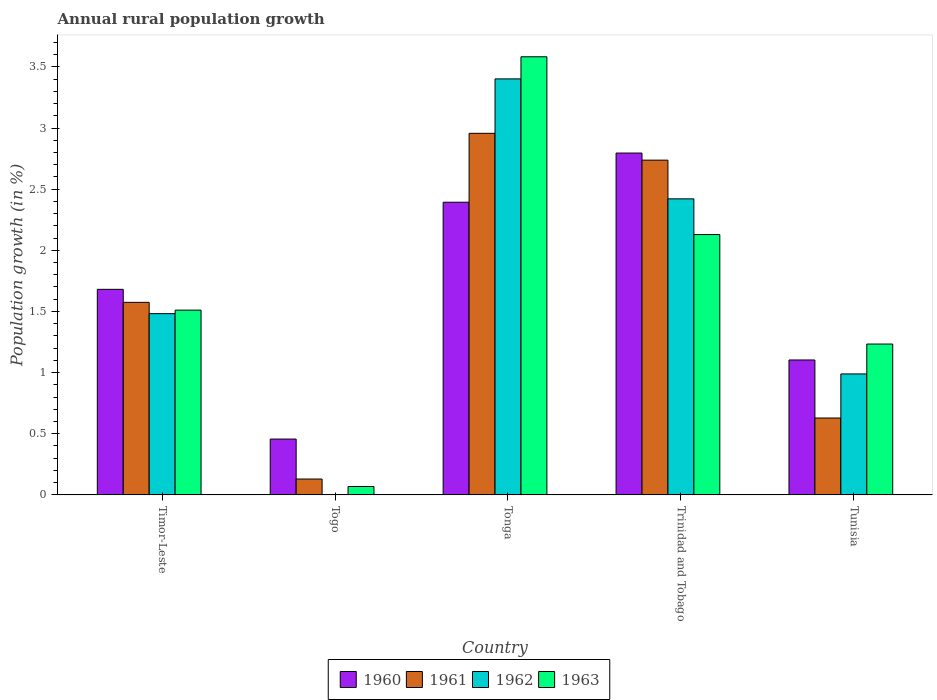How many different coloured bars are there?
Your response must be concise. 4. How many bars are there on the 2nd tick from the left?
Offer a terse response. 3. What is the label of the 1st group of bars from the left?
Make the answer very short. Timor-Leste. What is the percentage of rural population growth in 1960 in Timor-Leste?
Offer a terse response. 1.68. Across all countries, what is the maximum percentage of rural population growth in 1961?
Provide a short and direct response. 2.96. Across all countries, what is the minimum percentage of rural population growth in 1960?
Give a very brief answer. 0.46. In which country was the percentage of rural population growth in 1963 maximum?
Your answer should be very brief. Tonga. What is the total percentage of rural population growth in 1961 in the graph?
Provide a short and direct response. 8.03. What is the difference between the percentage of rural population growth in 1961 in Tonga and that in Tunisia?
Offer a very short reply. 2.33. What is the difference between the percentage of rural population growth in 1961 in Togo and the percentage of rural population growth in 1960 in Trinidad and Tobago?
Provide a short and direct response. -2.67. What is the average percentage of rural population growth in 1963 per country?
Provide a short and direct response. 1.7. What is the difference between the percentage of rural population growth of/in 1963 and percentage of rural population growth of/in 1960 in Trinidad and Tobago?
Offer a terse response. -0.67. In how many countries, is the percentage of rural population growth in 1963 greater than 3.1 %?
Make the answer very short. 1. What is the ratio of the percentage of rural population growth in 1960 in Togo to that in Tonga?
Give a very brief answer. 0.19. Is the difference between the percentage of rural population growth in 1963 in Trinidad and Tobago and Tunisia greater than the difference between the percentage of rural population growth in 1960 in Trinidad and Tobago and Tunisia?
Offer a very short reply. No. What is the difference between the highest and the second highest percentage of rural population growth in 1963?
Provide a short and direct response. -0.62. What is the difference between the highest and the lowest percentage of rural population growth in 1960?
Make the answer very short. 2.34. In how many countries, is the percentage of rural population growth in 1960 greater than the average percentage of rural population growth in 1960 taken over all countries?
Your response must be concise. 2. Is the sum of the percentage of rural population growth in 1963 in Togo and Tunisia greater than the maximum percentage of rural population growth in 1960 across all countries?
Offer a very short reply. No. Is it the case that in every country, the sum of the percentage of rural population growth in 1962 and percentage of rural population growth in 1961 is greater than the percentage of rural population growth in 1963?
Give a very brief answer. Yes. How many countries are there in the graph?
Make the answer very short. 5. What is the difference between two consecutive major ticks on the Y-axis?
Keep it short and to the point. 0.5. Where does the legend appear in the graph?
Keep it short and to the point. Bottom center. How many legend labels are there?
Provide a succinct answer. 4. What is the title of the graph?
Provide a succinct answer. Annual rural population growth. Does "1981" appear as one of the legend labels in the graph?
Make the answer very short. No. What is the label or title of the Y-axis?
Offer a terse response. Population growth (in %). What is the Population growth (in %) in 1960 in Timor-Leste?
Offer a terse response. 1.68. What is the Population growth (in %) in 1961 in Timor-Leste?
Provide a succinct answer. 1.57. What is the Population growth (in %) in 1962 in Timor-Leste?
Offer a terse response. 1.48. What is the Population growth (in %) of 1963 in Timor-Leste?
Give a very brief answer. 1.51. What is the Population growth (in %) of 1960 in Togo?
Your answer should be very brief. 0.46. What is the Population growth (in %) in 1961 in Togo?
Make the answer very short. 0.13. What is the Population growth (in %) of 1962 in Togo?
Provide a short and direct response. 0. What is the Population growth (in %) of 1963 in Togo?
Ensure brevity in your answer.  0.07. What is the Population growth (in %) of 1960 in Tonga?
Your response must be concise. 2.39. What is the Population growth (in %) of 1961 in Tonga?
Keep it short and to the point. 2.96. What is the Population growth (in %) of 1962 in Tonga?
Your answer should be compact. 3.4. What is the Population growth (in %) in 1963 in Tonga?
Your response must be concise. 3.58. What is the Population growth (in %) in 1960 in Trinidad and Tobago?
Give a very brief answer. 2.8. What is the Population growth (in %) in 1961 in Trinidad and Tobago?
Your answer should be compact. 2.74. What is the Population growth (in %) in 1962 in Trinidad and Tobago?
Provide a succinct answer. 2.42. What is the Population growth (in %) in 1963 in Trinidad and Tobago?
Ensure brevity in your answer.  2.13. What is the Population growth (in %) in 1960 in Tunisia?
Offer a very short reply. 1.1. What is the Population growth (in %) in 1961 in Tunisia?
Give a very brief answer. 0.63. What is the Population growth (in %) in 1962 in Tunisia?
Provide a succinct answer. 0.99. What is the Population growth (in %) in 1963 in Tunisia?
Provide a short and direct response. 1.23. Across all countries, what is the maximum Population growth (in %) in 1960?
Your answer should be compact. 2.8. Across all countries, what is the maximum Population growth (in %) of 1961?
Offer a terse response. 2.96. Across all countries, what is the maximum Population growth (in %) in 1962?
Your answer should be very brief. 3.4. Across all countries, what is the maximum Population growth (in %) of 1963?
Give a very brief answer. 3.58. Across all countries, what is the minimum Population growth (in %) in 1960?
Your response must be concise. 0.46. Across all countries, what is the minimum Population growth (in %) in 1961?
Give a very brief answer. 0.13. Across all countries, what is the minimum Population growth (in %) in 1963?
Give a very brief answer. 0.07. What is the total Population growth (in %) in 1960 in the graph?
Offer a terse response. 8.43. What is the total Population growth (in %) of 1961 in the graph?
Provide a succinct answer. 8.03. What is the total Population growth (in %) of 1962 in the graph?
Make the answer very short. 8.29. What is the total Population growth (in %) in 1963 in the graph?
Give a very brief answer. 8.52. What is the difference between the Population growth (in %) of 1960 in Timor-Leste and that in Togo?
Ensure brevity in your answer.  1.22. What is the difference between the Population growth (in %) of 1961 in Timor-Leste and that in Togo?
Ensure brevity in your answer.  1.44. What is the difference between the Population growth (in %) in 1963 in Timor-Leste and that in Togo?
Offer a terse response. 1.44. What is the difference between the Population growth (in %) in 1960 in Timor-Leste and that in Tonga?
Your answer should be compact. -0.71. What is the difference between the Population growth (in %) in 1961 in Timor-Leste and that in Tonga?
Offer a terse response. -1.38. What is the difference between the Population growth (in %) in 1962 in Timor-Leste and that in Tonga?
Your answer should be very brief. -1.92. What is the difference between the Population growth (in %) in 1963 in Timor-Leste and that in Tonga?
Offer a very short reply. -2.07. What is the difference between the Population growth (in %) in 1960 in Timor-Leste and that in Trinidad and Tobago?
Your response must be concise. -1.11. What is the difference between the Population growth (in %) in 1961 in Timor-Leste and that in Trinidad and Tobago?
Give a very brief answer. -1.16. What is the difference between the Population growth (in %) of 1962 in Timor-Leste and that in Trinidad and Tobago?
Make the answer very short. -0.94. What is the difference between the Population growth (in %) of 1963 in Timor-Leste and that in Trinidad and Tobago?
Give a very brief answer. -0.62. What is the difference between the Population growth (in %) of 1960 in Timor-Leste and that in Tunisia?
Give a very brief answer. 0.58. What is the difference between the Population growth (in %) of 1961 in Timor-Leste and that in Tunisia?
Offer a terse response. 0.95. What is the difference between the Population growth (in %) of 1962 in Timor-Leste and that in Tunisia?
Give a very brief answer. 0.49. What is the difference between the Population growth (in %) in 1963 in Timor-Leste and that in Tunisia?
Give a very brief answer. 0.28. What is the difference between the Population growth (in %) of 1960 in Togo and that in Tonga?
Provide a short and direct response. -1.94. What is the difference between the Population growth (in %) in 1961 in Togo and that in Tonga?
Your answer should be very brief. -2.83. What is the difference between the Population growth (in %) of 1963 in Togo and that in Tonga?
Your answer should be compact. -3.51. What is the difference between the Population growth (in %) of 1960 in Togo and that in Trinidad and Tobago?
Provide a short and direct response. -2.34. What is the difference between the Population growth (in %) in 1961 in Togo and that in Trinidad and Tobago?
Your answer should be compact. -2.61. What is the difference between the Population growth (in %) in 1963 in Togo and that in Trinidad and Tobago?
Make the answer very short. -2.06. What is the difference between the Population growth (in %) of 1960 in Togo and that in Tunisia?
Provide a succinct answer. -0.65. What is the difference between the Population growth (in %) of 1961 in Togo and that in Tunisia?
Offer a terse response. -0.5. What is the difference between the Population growth (in %) in 1963 in Togo and that in Tunisia?
Make the answer very short. -1.17. What is the difference between the Population growth (in %) of 1960 in Tonga and that in Trinidad and Tobago?
Your response must be concise. -0.4. What is the difference between the Population growth (in %) in 1961 in Tonga and that in Trinidad and Tobago?
Ensure brevity in your answer.  0.22. What is the difference between the Population growth (in %) of 1962 in Tonga and that in Trinidad and Tobago?
Your answer should be very brief. 0.98. What is the difference between the Population growth (in %) of 1963 in Tonga and that in Trinidad and Tobago?
Ensure brevity in your answer.  1.45. What is the difference between the Population growth (in %) of 1960 in Tonga and that in Tunisia?
Offer a terse response. 1.29. What is the difference between the Population growth (in %) of 1961 in Tonga and that in Tunisia?
Your answer should be compact. 2.33. What is the difference between the Population growth (in %) of 1962 in Tonga and that in Tunisia?
Your response must be concise. 2.41. What is the difference between the Population growth (in %) of 1963 in Tonga and that in Tunisia?
Your answer should be very brief. 2.35. What is the difference between the Population growth (in %) in 1960 in Trinidad and Tobago and that in Tunisia?
Make the answer very short. 1.69. What is the difference between the Population growth (in %) in 1961 in Trinidad and Tobago and that in Tunisia?
Make the answer very short. 2.11. What is the difference between the Population growth (in %) in 1962 in Trinidad and Tobago and that in Tunisia?
Give a very brief answer. 1.43. What is the difference between the Population growth (in %) in 1963 in Trinidad and Tobago and that in Tunisia?
Ensure brevity in your answer.  0.9. What is the difference between the Population growth (in %) of 1960 in Timor-Leste and the Population growth (in %) of 1961 in Togo?
Give a very brief answer. 1.55. What is the difference between the Population growth (in %) of 1960 in Timor-Leste and the Population growth (in %) of 1963 in Togo?
Offer a terse response. 1.61. What is the difference between the Population growth (in %) of 1961 in Timor-Leste and the Population growth (in %) of 1963 in Togo?
Offer a terse response. 1.51. What is the difference between the Population growth (in %) of 1962 in Timor-Leste and the Population growth (in %) of 1963 in Togo?
Provide a succinct answer. 1.41. What is the difference between the Population growth (in %) in 1960 in Timor-Leste and the Population growth (in %) in 1961 in Tonga?
Offer a very short reply. -1.28. What is the difference between the Population growth (in %) of 1960 in Timor-Leste and the Population growth (in %) of 1962 in Tonga?
Provide a succinct answer. -1.72. What is the difference between the Population growth (in %) of 1960 in Timor-Leste and the Population growth (in %) of 1963 in Tonga?
Provide a short and direct response. -1.9. What is the difference between the Population growth (in %) in 1961 in Timor-Leste and the Population growth (in %) in 1962 in Tonga?
Offer a very short reply. -1.83. What is the difference between the Population growth (in %) in 1961 in Timor-Leste and the Population growth (in %) in 1963 in Tonga?
Offer a very short reply. -2.01. What is the difference between the Population growth (in %) of 1962 in Timor-Leste and the Population growth (in %) of 1963 in Tonga?
Your answer should be compact. -2.1. What is the difference between the Population growth (in %) in 1960 in Timor-Leste and the Population growth (in %) in 1961 in Trinidad and Tobago?
Give a very brief answer. -1.06. What is the difference between the Population growth (in %) in 1960 in Timor-Leste and the Population growth (in %) in 1962 in Trinidad and Tobago?
Give a very brief answer. -0.74. What is the difference between the Population growth (in %) of 1960 in Timor-Leste and the Population growth (in %) of 1963 in Trinidad and Tobago?
Keep it short and to the point. -0.45. What is the difference between the Population growth (in %) of 1961 in Timor-Leste and the Population growth (in %) of 1962 in Trinidad and Tobago?
Your answer should be compact. -0.85. What is the difference between the Population growth (in %) in 1961 in Timor-Leste and the Population growth (in %) in 1963 in Trinidad and Tobago?
Give a very brief answer. -0.55. What is the difference between the Population growth (in %) of 1962 in Timor-Leste and the Population growth (in %) of 1963 in Trinidad and Tobago?
Ensure brevity in your answer.  -0.65. What is the difference between the Population growth (in %) of 1960 in Timor-Leste and the Population growth (in %) of 1961 in Tunisia?
Your answer should be very brief. 1.05. What is the difference between the Population growth (in %) in 1960 in Timor-Leste and the Population growth (in %) in 1962 in Tunisia?
Provide a succinct answer. 0.69. What is the difference between the Population growth (in %) of 1960 in Timor-Leste and the Population growth (in %) of 1963 in Tunisia?
Offer a terse response. 0.45. What is the difference between the Population growth (in %) in 1961 in Timor-Leste and the Population growth (in %) in 1962 in Tunisia?
Give a very brief answer. 0.59. What is the difference between the Population growth (in %) of 1961 in Timor-Leste and the Population growth (in %) of 1963 in Tunisia?
Your answer should be very brief. 0.34. What is the difference between the Population growth (in %) of 1962 in Timor-Leste and the Population growth (in %) of 1963 in Tunisia?
Keep it short and to the point. 0.25. What is the difference between the Population growth (in %) in 1960 in Togo and the Population growth (in %) in 1961 in Tonga?
Keep it short and to the point. -2.5. What is the difference between the Population growth (in %) in 1960 in Togo and the Population growth (in %) in 1962 in Tonga?
Give a very brief answer. -2.94. What is the difference between the Population growth (in %) in 1960 in Togo and the Population growth (in %) in 1963 in Tonga?
Provide a short and direct response. -3.13. What is the difference between the Population growth (in %) of 1961 in Togo and the Population growth (in %) of 1962 in Tonga?
Your answer should be very brief. -3.27. What is the difference between the Population growth (in %) in 1961 in Togo and the Population growth (in %) in 1963 in Tonga?
Your answer should be very brief. -3.45. What is the difference between the Population growth (in %) in 1960 in Togo and the Population growth (in %) in 1961 in Trinidad and Tobago?
Make the answer very short. -2.28. What is the difference between the Population growth (in %) in 1960 in Togo and the Population growth (in %) in 1962 in Trinidad and Tobago?
Give a very brief answer. -1.96. What is the difference between the Population growth (in %) in 1960 in Togo and the Population growth (in %) in 1963 in Trinidad and Tobago?
Provide a succinct answer. -1.67. What is the difference between the Population growth (in %) of 1961 in Togo and the Population growth (in %) of 1962 in Trinidad and Tobago?
Provide a short and direct response. -2.29. What is the difference between the Population growth (in %) in 1961 in Togo and the Population growth (in %) in 1963 in Trinidad and Tobago?
Provide a short and direct response. -2. What is the difference between the Population growth (in %) in 1960 in Togo and the Population growth (in %) in 1961 in Tunisia?
Provide a succinct answer. -0.17. What is the difference between the Population growth (in %) in 1960 in Togo and the Population growth (in %) in 1962 in Tunisia?
Keep it short and to the point. -0.53. What is the difference between the Population growth (in %) of 1960 in Togo and the Population growth (in %) of 1963 in Tunisia?
Give a very brief answer. -0.78. What is the difference between the Population growth (in %) in 1961 in Togo and the Population growth (in %) in 1962 in Tunisia?
Make the answer very short. -0.86. What is the difference between the Population growth (in %) of 1961 in Togo and the Population growth (in %) of 1963 in Tunisia?
Your answer should be very brief. -1.1. What is the difference between the Population growth (in %) in 1960 in Tonga and the Population growth (in %) in 1961 in Trinidad and Tobago?
Your answer should be very brief. -0.34. What is the difference between the Population growth (in %) of 1960 in Tonga and the Population growth (in %) of 1962 in Trinidad and Tobago?
Provide a succinct answer. -0.03. What is the difference between the Population growth (in %) in 1960 in Tonga and the Population growth (in %) in 1963 in Trinidad and Tobago?
Offer a terse response. 0.26. What is the difference between the Population growth (in %) of 1961 in Tonga and the Population growth (in %) of 1962 in Trinidad and Tobago?
Your answer should be very brief. 0.54. What is the difference between the Population growth (in %) in 1961 in Tonga and the Population growth (in %) in 1963 in Trinidad and Tobago?
Offer a terse response. 0.83. What is the difference between the Population growth (in %) of 1962 in Tonga and the Population growth (in %) of 1963 in Trinidad and Tobago?
Give a very brief answer. 1.27. What is the difference between the Population growth (in %) of 1960 in Tonga and the Population growth (in %) of 1961 in Tunisia?
Provide a succinct answer. 1.76. What is the difference between the Population growth (in %) of 1960 in Tonga and the Population growth (in %) of 1962 in Tunisia?
Keep it short and to the point. 1.4. What is the difference between the Population growth (in %) in 1960 in Tonga and the Population growth (in %) in 1963 in Tunisia?
Your answer should be very brief. 1.16. What is the difference between the Population growth (in %) in 1961 in Tonga and the Population growth (in %) in 1962 in Tunisia?
Offer a very short reply. 1.97. What is the difference between the Population growth (in %) in 1961 in Tonga and the Population growth (in %) in 1963 in Tunisia?
Give a very brief answer. 1.72. What is the difference between the Population growth (in %) in 1962 in Tonga and the Population growth (in %) in 1963 in Tunisia?
Provide a succinct answer. 2.17. What is the difference between the Population growth (in %) of 1960 in Trinidad and Tobago and the Population growth (in %) of 1961 in Tunisia?
Your answer should be compact. 2.17. What is the difference between the Population growth (in %) in 1960 in Trinidad and Tobago and the Population growth (in %) in 1962 in Tunisia?
Your response must be concise. 1.81. What is the difference between the Population growth (in %) in 1960 in Trinidad and Tobago and the Population growth (in %) in 1963 in Tunisia?
Your answer should be compact. 1.56. What is the difference between the Population growth (in %) of 1961 in Trinidad and Tobago and the Population growth (in %) of 1962 in Tunisia?
Your answer should be compact. 1.75. What is the difference between the Population growth (in %) in 1961 in Trinidad and Tobago and the Population growth (in %) in 1963 in Tunisia?
Give a very brief answer. 1.5. What is the difference between the Population growth (in %) of 1962 in Trinidad and Tobago and the Population growth (in %) of 1963 in Tunisia?
Offer a terse response. 1.19. What is the average Population growth (in %) of 1960 per country?
Provide a short and direct response. 1.69. What is the average Population growth (in %) in 1961 per country?
Your answer should be very brief. 1.61. What is the average Population growth (in %) of 1962 per country?
Give a very brief answer. 1.66. What is the average Population growth (in %) of 1963 per country?
Offer a very short reply. 1.7. What is the difference between the Population growth (in %) of 1960 and Population growth (in %) of 1961 in Timor-Leste?
Give a very brief answer. 0.11. What is the difference between the Population growth (in %) of 1960 and Population growth (in %) of 1962 in Timor-Leste?
Keep it short and to the point. 0.2. What is the difference between the Population growth (in %) of 1960 and Population growth (in %) of 1963 in Timor-Leste?
Your answer should be compact. 0.17. What is the difference between the Population growth (in %) of 1961 and Population growth (in %) of 1962 in Timor-Leste?
Provide a short and direct response. 0.09. What is the difference between the Population growth (in %) of 1961 and Population growth (in %) of 1963 in Timor-Leste?
Your answer should be compact. 0.06. What is the difference between the Population growth (in %) in 1962 and Population growth (in %) in 1963 in Timor-Leste?
Provide a succinct answer. -0.03. What is the difference between the Population growth (in %) of 1960 and Population growth (in %) of 1961 in Togo?
Make the answer very short. 0.33. What is the difference between the Population growth (in %) of 1960 and Population growth (in %) of 1963 in Togo?
Your answer should be compact. 0.39. What is the difference between the Population growth (in %) of 1961 and Population growth (in %) of 1963 in Togo?
Your answer should be very brief. 0.06. What is the difference between the Population growth (in %) in 1960 and Population growth (in %) in 1961 in Tonga?
Offer a very short reply. -0.56. What is the difference between the Population growth (in %) of 1960 and Population growth (in %) of 1962 in Tonga?
Give a very brief answer. -1.01. What is the difference between the Population growth (in %) of 1960 and Population growth (in %) of 1963 in Tonga?
Offer a very short reply. -1.19. What is the difference between the Population growth (in %) in 1961 and Population growth (in %) in 1962 in Tonga?
Provide a short and direct response. -0.44. What is the difference between the Population growth (in %) in 1961 and Population growth (in %) in 1963 in Tonga?
Offer a terse response. -0.63. What is the difference between the Population growth (in %) of 1962 and Population growth (in %) of 1963 in Tonga?
Your response must be concise. -0.18. What is the difference between the Population growth (in %) of 1960 and Population growth (in %) of 1961 in Trinidad and Tobago?
Keep it short and to the point. 0.06. What is the difference between the Population growth (in %) of 1960 and Population growth (in %) of 1962 in Trinidad and Tobago?
Ensure brevity in your answer.  0.37. What is the difference between the Population growth (in %) of 1960 and Population growth (in %) of 1963 in Trinidad and Tobago?
Your answer should be very brief. 0.67. What is the difference between the Population growth (in %) of 1961 and Population growth (in %) of 1962 in Trinidad and Tobago?
Ensure brevity in your answer.  0.32. What is the difference between the Population growth (in %) of 1961 and Population growth (in %) of 1963 in Trinidad and Tobago?
Ensure brevity in your answer.  0.61. What is the difference between the Population growth (in %) in 1962 and Population growth (in %) in 1963 in Trinidad and Tobago?
Your answer should be compact. 0.29. What is the difference between the Population growth (in %) of 1960 and Population growth (in %) of 1961 in Tunisia?
Your response must be concise. 0.47. What is the difference between the Population growth (in %) of 1960 and Population growth (in %) of 1962 in Tunisia?
Your response must be concise. 0.11. What is the difference between the Population growth (in %) of 1960 and Population growth (in %) of 1963 in Tunisia?
Provide a succinct answer. -0.13. What is the difference between the Population growth (in %) in 1961 and Population growth (in %) in 1962 in Tunisia?
Your response must be concise. -0.36. What is the difference between the Population growth (in %) of 1961 and Population growth (in %) of 1963 in Tunisia?
Provide a succinct answer. -0.6. What is the difference between the Population growth (in %) in 1962 and Population growth (in %) in 1963 in Tunisia?
Your response must be concise. -0.24. What is the ratio of the Population growth (in %) in 1960 in Timor-Leste to that in Togo?
Your answer should be very brief. 3.68. What is the ratio of the Population growth (in %) of 1961 in Timor-Leste to that in Togo?
Make the answer very short. 12.13. What is the ratio of the Population growth (in %) of 1963 in Timor-Leste to that in Togo?
Your answer should be very brief. 22.04. What is the ratio of the Population growth (in %) of 1960 in Timor-Leste to that in Tonga?
Offer a terse response. 0.7. What is the ratio of the Population growth (in %) of 1961 in Timor-Leste to that in Tonga?
Offer a very short reply. 0.53. What is the ratio of the Population growth (in %) of 1962 in Timor-Leste to that in Tonga?
Offer a terse response. 0.44. What is the ratio of the Population growth (in %) of 1963 in Timor-Leste to that in Tonga?
Offer a very short reply. 0.42. What is the ratio of the Population growth (in %) in 1960 in Timor-Leste to that in Trinidad and Tobago?
Ensure brevity in your answer.  0.6. What is the ratio of the Population growth (in %) of 1961 in Timor-Leste to that in Trinidad and Tobago?
Give a very brief answer. 0.58. What is the ratio of the Population growth (in %) of 1962 in Timor-Leste to that in Trinidad and Tobago?
Keep it short and to the point. 0.61. What is the ratio of the Population growth (in %) of 1963 in Timor-Leste to that in Trinidad and Tobago?
Make the answer very short. 0.71. What is the ratio of the Population growth (in %) of 1960 in Timor-Leste to that in Tunisia?
Provide a short and direct response. 1.52. What is the ratio of the Population growth (in %) in 1961 in Timor-Leste to that in Tunisia?
Ensure brevity in your answer.  2.5. What is the ratio of the Population growth (in %) in 1962 in Timor-Leste to that in Tunisia?
Provide a short and direct response. 1.5. What is the ratio of the Population growth (in %) in 1963 in Timor-Leste to that in Tunisia?
Your answer should be compact. 1.22. What is the ratio of the Population growth (in %) of 1960 in Togo to that in Tonga?
Your response must be concise. 0.19. What is the ratio of the Population growth (in %) of 1961 in Togo to that in Tonga?
Your response must be concise. 0.04. What is the ratio of the Population growth (in %) in 1963 in Togo to that in Tonga?
Keep it short and to the point. 0.02. What is the ratio of the Population growth (in %) in 1960 in Togo to that in Trinidad and Tobago?
Keep it short and to the point. 0.16. What is the ratio of the Population growth (in %) of 1961 in Togo to that in Trinidad and Tobago?
Your answer should be very brief. 0.05. What is the ratio of the Population growth (in %) of 1963 in Togo to that in Trinidad and Tobago?
Your response must be concise. 0.03. What is the ratio of the Population growth (in %) in 1960 in Togo to that in Tunisia?
Your answer should be compact. 0.41. What is the ratio of the Population growth (in %) in 1961 in Togo to that in Tunisia?
Provide a succinct answer. 0.21. What is the ratio of the Population growth (in %) in 1963 in Togo to that in Tunisia?
Provide a short and direct response. 0.06. What is the ratio of the Population growth (in %) of 1960 in Tonga to that in Trinidad and Tobago?
Keep it short and to the point. 0.86. What is the ratio of the Population growth (in %) of 1961 in Tonga to that in Trinidad and Tobago?
Make the answer very short. 1.08. What is the ratio of the Population growth (in %) in 1962 in Tonga to that in Trinidad and Tobago?
Your response must be concise. 1.41. What is the ratio of the Population growth (in %) of 1963 in Tonga to that in Trinidad and Tobago?
Your answer should be very brief. 1.68. What is the ratio of the Population growth (in %) of 1960 in Tonga to that in Tunisia?
Your answer should be very brief. 2.17. What is the ratio of the Population growth (in %) in 1961 in Tonga to that in Tunisia?
Your answer should be very brief. 4.7. What is the ratio of the Population growth (in %) of 1962 in Tonga to that in Tunisia?
Give a very brief answer. 3.44. What is the ratio of the Population growth (in %) of 1963 in Tonga to that in Tunisia?
Keep it short and to the point. 2.9. What is the ratio of the Population growth (in %) of 1960 in Trinidad and Tobago to that in Tunisia?
Offer a very short reply. 2.53. What is the ratio of the Population growth (in %) in 1961 in Trinidad and Tobago to that in Tunisia?
Give a very brief answer. 4.35. What is the ratio of the Population growth (in %) of 1962 in Trinidad and Tobago to that in Tunisia?
Ensure brevity in your answer.  2.45. What is the ratio of the Population growth (in %) in 1963 in Trinidad and Tobago to that in Tunisia?
Offer a terse response. 1.73. What is the difference between the highest and the second highest Population growth (in %) of 1960?
Your answer should be very brief. 0.4. What is the difference between the highest and the second highest Population growth (in %) in 1961?
Your answer should be compact. 0.22. What is the difference between the highest and the second highest Population growth (in %) of 1962?
Offer a very short reply. 0.98. What is the difference between the highest and the second highest Population growth (in %) in 1963?
Your answer should be very brief. 1.45. What is the difference between the highest and the lowest Population growth (in %) in 1960?
Keep it short and to the point. 2.34. What is the difference between the highest and the lowest Population growth (in %) in 1961?
Ensure brevity in your answer.  2.83. What is the difference between the highest and the lowest Population growth (in %) of 1962?
Provide a short and direct response. 3.4. What is the difference between the highest and the lowest Population growth (in %) of 1963?
Give a very brief answer. 3.51. 